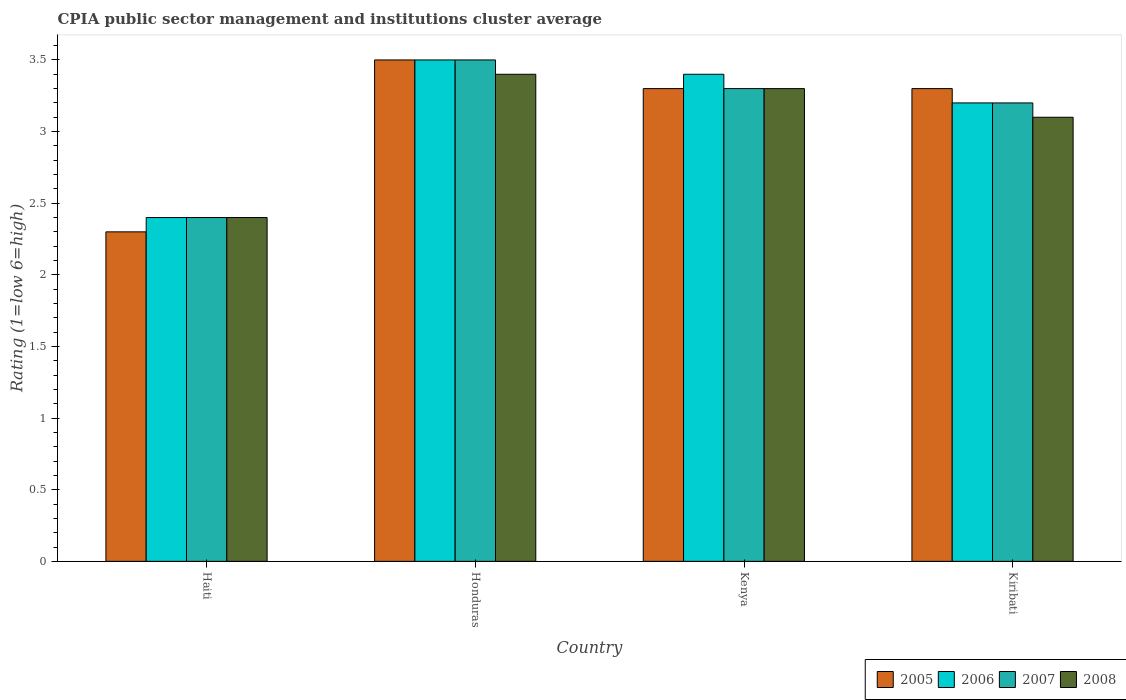How many groups of bars are there?
Offer a very short reply. 4. Are the number of bars on each tick of the X-axis equal?
Provide a short and direct response. Yes. What is the label of the 4th group of bars from the left?
Make the answer very short. Kiribati. What is the CPIA rating in 2008 in Kiribati?
Provide a short and direct response. 3.1. In which country was the CPIA rating in 2008 maximum?
Offer a terse response. Honduras. In which country was the CPIA rating in 2007 minimum?
Offer a very short reply. Haiti. What is the difference between the CPIA rating in 2007 in Haiti and that in Honduras?
Your answer should be very brief. -1.1. What is the difference between the CPIA rating in 2008 in Kiribati and the CPIA rating in 2005 in Honduras?
Provide a succinct answer. -0.4. What is the average CPIA rating in 2007 per country?
Ensure brevity in your answer.  3.1. What is the difference between the CPIA rating of/in 2008 and CPIA rating of/in 2005 in Kiribati?
Your answer should be very brief. -0.2. What is the ratio of the CPIA rating in 2008 in Honduras to that in Kenya?
Keep it short and to the point. 1.03. What is the difference between the highest and the second highest CPIA rating in 2007?
Offer a terse response. -0.2. What is the difference between the highest and the lowest CPIA rating in 2008?
Ensure brevity in your answer.  1. In how many countries, is the CPIA rating in 2008 greater than the average CPIA rating in 2008 taken over all countries?
Ensure brevity in your answer.  3. What does the 2nd bar from the right in Honduras represents?
Your answer should be compact. 2007. How many bars are there?
Ensure brevity in your answer.  16. Are all the bars in the graph horizontal?
Ensure brevity in your answer.  No. Are the values on the major ticks of Y-axis written in scientific E-notation?
Your response must be concise. No. Does the graph contain any zero values?
Offer a very short reply. No. Does the graph contain grids?
Your answer should be very brief. No. How are the legend labels stacked?
Make the answer very short. Horizontal. What is the title of the graph?
Provide a short and direct response. CPIA public sector management and institutions cluster average. What is the Rating (1=low 6=high) in 2005 in Haiti?
Your response must be concise. 2.3. What is the Rating (1=low 6=high) of 2006 in Haiti?
Offer a very short reply. 2.4. What is the Rating (1=low 6=high) of 2007 in Haiti?
Make the answer very short. 2.4. What is the Rating (1=low 6=high) in 2008 in Haiti?
Your response must be concise. 2.4. What is the Rating (1=low 6=high) of 2005 in Honduras?
Give a very brief answer. 3.5. What is the Rating (1=low 6=high) of 2008 in Honduras?
Ensure brevity in your answer.  3.4. What is the Rating (1=low 6=high) in 2005 in Kenya?
Your response must be concise. 3.3. What is the Rating (1=low 6=high) of 2006 in Kenya?
Give a very brief answer. 3.4. What is the Rating (1=low 6=high) in 2008 in Kenya?
Give a very brief answer. 3.3. Across all countries, what is the maximum Rating (1=low 6=high) in 2006?
Provide a short and direct response. 3.5. Across all countries, what is the maximum Rating (1=low 6=high) in 2008?
Provide a succinct answer. 3.4. Across all countries, what is the minimum Rating (1=low 6=high) of 2005?
Give a very brief answer. 2.3. Across all countries, what is the minimum Rating (1=low 6=high) of 2006?
Make the answer very short. 2.4. Across all countries, what is the minimum Rating (1=low 6=high) of 2008?
Offer a very short reply. 2.4. What is the total Rating (1=low 6=high) in 2005 in the graph?
Make the answer very short. 12.4. What is the total Rating (1=low 6=high) in 2006 in the graph?
Provide a succinct answer. 12.5. What is the difference between the Rating (1=low 6=high) in 2005 in Haiti and that in Honduras?
Provide a short and direct response. -1.2. What is the difference between the Rating (1=low 6=high) of 2006 in Haiti and that in Honduras?
Offer a very short reply. -1.1. What is the difference between the Rating (1=low 6=high) of 2007 in Haiti and that in Honduras?
Offer a very short reply. -1.1. What is the difference between the Rating (1=low 6=high) of 2006 in Haiti and that in Kiribati?
Give a very brief answer. -0.8. What is the difference between the Rating (1=low 6=high) of 2008 in Haiti and that in Kiribati?
Offer a terse response. -0.7. What is the difference between the Rating (1=low 6=high) of 2005 in Honduras and that in Kenya?
Your answer should be compact. 0.2. What is the difference between the Rating (1=low 6=high) of 2006 in Honduras and that in Kenya?
Ensure brevity in your answer.  0.1. What is the difference between the Rating (1=low 6=high) in 2008 in Honduras and that in Kenya?
Your answer should be very brief. 0.1. What is the difference between the Rating (1=low 6=high) of 2005 in Honduras and that in Kiribati?
Ensure brevity in your answer.  0.2. What is the difference between the Rating (1=low 6=high) in 2006 in Honduras and that in Kiribati?
Provide a succinct answer. 0.3. What is the difference between the Rating (1=low 6=high) of 2007 in Honduras and that in Kiribati?
Ensure brevity in your answer.  0.3. What is the difference between the Rating (1=low 6=high) of 2008 in Honduras and that in Kiribati?
Offer a very short reply. 0.3. What is the difference between the Rating (1=low 6=high) of 2006 in Kenya and that in Kiribati?
Your response must be concise. 0.2. What is the difference between the Rating (1=low 6=high) in 2005 in Haiti and the Rating (1=low 6=high) in 2006 in Honduras?
Ensure brevity in your answer.  -1.2. What is the difference between the Rating (1=low 6=high) in 2005 in Haiti and the Rating (1=low 6=high) in 2008 in Honduras?
Keep it short and to the point. -1.1. What is the difference between the Rating (1=low 6=high) of 2006 in Haiti and the Rating (1=low 6=high) of 2007 in Honduras?
Make the answer very short. -1.1. What is the difference between the Rating (1=low 6=high) of 2006 in Haiti and the Rating (1=low 6=high) of 2008 in Honduras?
Offer a very short reply. -1. What is the difference between the Rating (1=low 6=high) in 2007 in Haiti and the Rating (1=low 6=high) in 2008 in Honduras?
Provide a succinct answer. -1. What is the difference between the Rating (1=low 6=high) of 2005 in Haiti and the Rating (1=low 6=high) of 2007 in Kenya?
Give a very brief answer. -1. What is the difference between the Rating (1=low 6=high) of 2006 in Haiti and the Rating (1=low 6=high) of 2007 in Kenya?
Provide a succinct answer. -0.9. What is the difference between the Rating (1=low 6=high) of 2006 in Haiti and the Rating (1=low 6=high) of 2008 in Kenya?
Your answer should be very brief. -0.9. What is the difference between the Rating (1=low 6=high) in 2007 in Haiti and the Rating (1=low 6=high) in 2008 in Kenya?
Your answer should be very brief. -0.9. What is the difference between the Rating (1=low 6=high) of 2005 in Haiti and the Rating (1=low 6=high) of 2007 in Kiribati?
Give a very brief answer. -0.9. What is the difference between the Rating (1=low 6=high) in 2006 in Haiti and the Rating (1=low 6=high) in 2008 in Kiribati?
Give a very brief answer. -0.7. What is the difference between the Rating (1=low 6=high) of 2007 in Haiti and the Rating (1=low 6=high) of 2008 in Kiribati?
Make the answer very short. -0.7. What is the difference between the Rating (1=low 6=high) of 2005 in Honduras and the Rating (1=low 6=high) of 2008 in Kenya?
Provide a short and direct response. 0.2. What is the difference between the Rating (1=low 6=high) of 2006 in Honduras and the Rating (1=low 6=high) of 2008 in Kenya?
Your answer should be very brief. 0.2. What is the difference between the Rating (1=low 6=high) of 2005 in Honduras and the Rating (1=low 6=high) of 2006 in Kiribati?
Offer a terse response. 0.3. What is the difference between the Rating (1=low 6=high) in 2005 in Honduras and the Rating (1=low 6=high) in 2008 in Kiribati?
Keep it short and to the point. 0.4. What is the difference between the Rating (1=low 6=high) of 2006 in Honduras and the Rating (1=low 6=high) of 2008 in Kiribati?
Your response must be concise. 0.4. What is the difference between the Rating (1=low 6=high) of 2005 in Kenya and the Rating (1=low 6=high) of 2008 in Kiribati?
Your response must be concise. 0.2. What is the difference between the Rating (1=low 6=high) in 2006 in Kenya and the Rating (1=low 6=high) in 2007 in Kiribati?
Keep it short and to the point. 0.2. What is the difference between the Rating (1=low 6=high) of 2006 in Kenya and the Rating (1=low 6=high) of 2008 in Kiribati?
Your answer should be compact. 0.3. What is the average Rating (1=low 6=high) of 2005 per country?
Your answer should be compact. 3.1. What is the average Rating (1=low 6=high) in 2006 per country?
Ensure brevity in your answer.  3.12. What is the average Rating (1=low 6=high) in 2007 per country?
Your response must be concise. 3.1. What is the average Rating (1=low 6=high) of 2008 per country?
Provide a succinct answer. 3.05. What is the difference between the Rating (1=low 6=high) of 2005 and Rating (1=low 6=high) of 2007 in Haiti?
Offer a very short reply. -0.1. What is the difference between the Rating (1=low 6=high) in 2006 and Rating (1=low 6=high) in 2007 in Haiti?
Ensure brevity in your answer.  0. What is the difference between the Rating (1=low 6=high) of 2006 and Rating (1=low 6=high) of 2008 in Haiti?
Your response must be concise. 0. What is the difference between the Rating (1=low 6=high) of 2005 and Rating (1=low 6=high) of 2006 in Honduras?
Your answer should be very brief. 0. What is the difference between the Rating (1=low 6=high) in 2005 and Rating (1=low 6=high) in 2007 in Honduras?
Keep it short and to the point. 0. What is the difference between the Rating (1=low 6=high) of 2005 and Rating (1=low 6=high) of 2008 in Honduras?
Provide a short and direct response. 0.1. What is the difference between the Rating (1=low 6=high) of 2005 and Rating (1=low 6=high) of 2007 in Kenya?
Give a very brief answer. 0. What is the difference between the Rating (1=low 6=high) of 2006 and Rating (1=low 6=high) of 2008 in Kenya?
Keep it short and to the point. 0.1. What is the difference between the Rating (1=low 6=high) in 2007 and Rating (1=low 6=high) in 2008 in Kenya?
Your response must be concise. 0. What is the difference between the Rating (1=low 6=high) in 2005 and Rating (1=low 6=high) in 2007 in Kiribati?
Make the answer very short. 0.1. What is the difference between the Rating (1=low 6=high) of 2005 and Rating (1=low 6=high) of 2008 in Kiribati?
Provide a succinct answer. 0.2. What is the difference between the Rating (1=low 6=high) of 2006 and Rating (1=low 6=high) of 2007 in Kiribati?
Your answer should be very brief. 0. What is the ratio of the Rating (1=low 6=high) in 2005 in Haiti to that in Honduras?
Your answer should be compact. 0.66. What is the ratio of the Rating (1=low 6=high) in 2006 in Haiti to that in Honduras?
Give a very brief answer. 0.69. What is the ratio of the Rating (1=low 6=high) in 2007 in Haiti to that in Honduras?
Offer a terse response. 0.69. What is the ratio of the Rating (1=low 6=high) in 2008 in Haiti to that in Honduras?
Provide a short and direct response. 0.71. What is the ratio of the Rating (1=low 6=high) in 2005 in Haiti to that in Kenya?
Offer a very short reply. 0.7. What is the ratio of the Rating (1=low 6=high) in 2006 in Haiti to that in Kenya?
Provide a succinct answer. 0.71. What is the ratio of the Rating (1=low 6=high) of 2007 in Haiti to that in Kenya?
Provide a succinct answer. 0.73. What is the ratio of the Rating (1=low 6=high) of 2008 in Haiti to that in Kenya?
Your answer should be compact. 0.73. What is the ratio of the Rating (1=low 6=high) in 2005 in Haiti to that in Kiribati?
Your response must be concise. 0.7. What is the ratio of the Rating (1=low 6=high) of 2008 in Haiti to that in Kiribati?
Keep it short and to the point. 0.77. What is the ratio of the Rating (1=low 6=high) in 2005 in Honduras to that in Kenya?
Your answer should be very brief. 1.06. What is the ratio of the Rating (1=low 6=high) in 2006 in Honduras to that in Kenya?
Ensure brevity in your answer.  1.03. What is the ratio of the Rating (1=low 6=high) of 2007 in Honduras to that in Kenya?
Your answer should be very brief. 1.06. What is the ratio of the Rating (1=low 6=high) in 2008 in Honduras to that in Kenya?
Give a very brief answer. 1.03. What is the ratio of the Rating (1=low 6=high) of 2005 in Honduras to that in Kiribati?
Provide a short and direct response. 1.06. What is the ratio of the Rating (1=low 6=high) of 2006 in Honduras to that in Kiribati?
Ensure brevity in your answer.  1.09. What is the ratio of the Rating (1=low 6=high) in 2007 in Honduras to that in Kiribati?
Provide a succinct answer. 1.09. What is the ratio of the Rating (1=low 6=high) of 2008 in Honduras to that in Kiribati?
Give a very brief answer. 1.1. What is the ratio of the Rating (1=low 6=high) of 2007 in Kenya to that in Kiribati?
Offer a very short reply. 1.03. What is the ratio of the Rating (1=low 6=high) in 2008 in Kenya to that in Kiribati?
Make the answer very short. 1.06. What is the difference between the highest and the second highest Rating (1=low 6=high) of 2006?
Provide a short and direct response. 0.1. What is the difference between the highest and the second highest Rating (1=low 6=high) in 2007?
Your response must be concise. 0.2. What is the difference between the highest and the lowest Rating (1=low 6=high) in 2005?
Your answer should be very brief. 1.2. What is the difference between the highest and the lowest Rating (1=low 6=high) in 2008?
Make the answer very short. 1. 